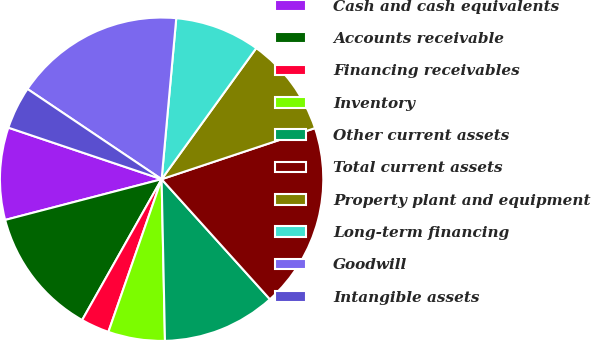<chart> <loc_0><loc_0><loc_500><loc_500><pie_chart><fcel>Cash and cash equivalents<fcel>Accounts receivable<fcel>Financing receivables<fcel>Inventory<fcel>Other current assets<fcel>Total current assets<fcel>Property plant and equipment<fcel>Long-term financing<fcel>Goodwill<fcel>Intangible assets<nl><fcel>9.22%<fcel>12.77%<fcel>2.84%<fcel>5.67%<fcel>11.35%<fcel>18.44%<fcel>9.93%<fcel>8.51%<fcel>17.02%<fcel>4.26%<nl></chart> 